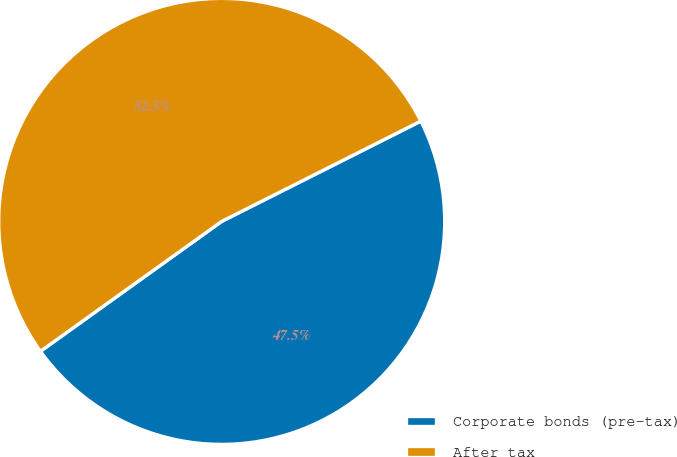Convert chart. <chart><loc_0><loc_0><loc_500><loc_500><pie_chart><fcel>Corporate bonds (pre-tax)<fcel>After tax<nl><fcel>47.53%<fcel>52.47%<nl></chart> 